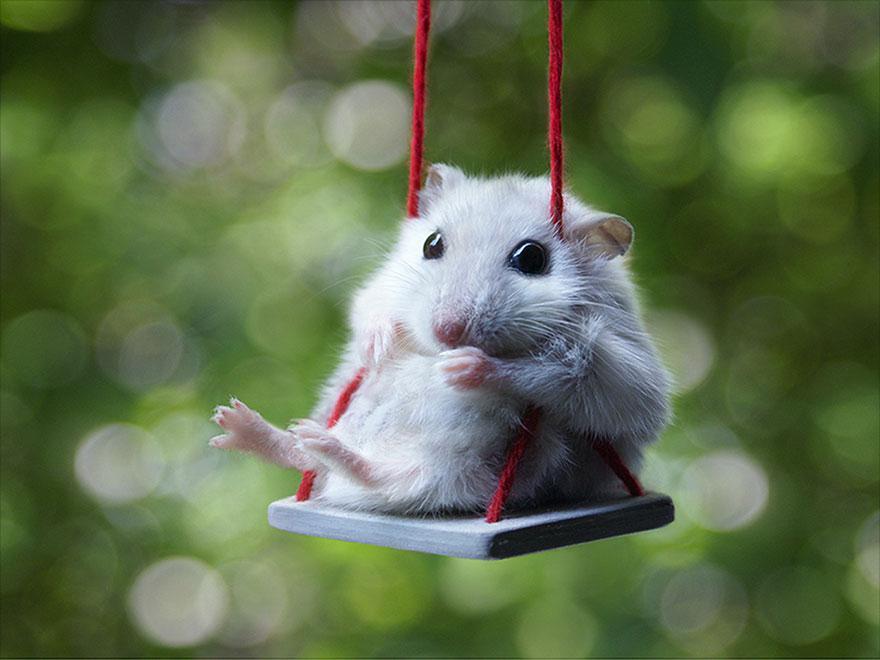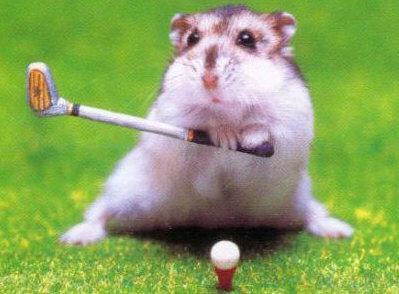The first image is the image on the left, the second image is the image on the right. Assess this claim about the two images: "A hamster is holding a string.". Correct or not? Answer yes or no. Yes. 